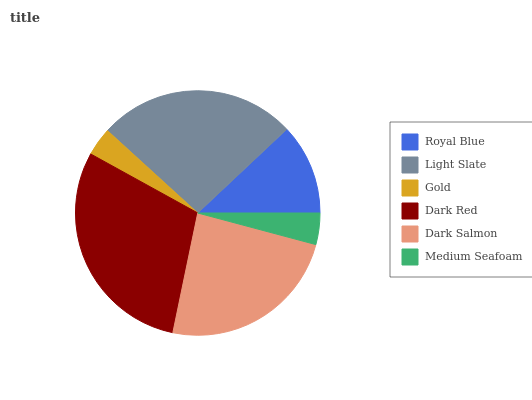Is Gold the minimum?
Answer yes or no. Yes. Is Dark Red the maximum?
Answer yes or no. Yes. Is Light Slate the minimum?
Answer yes or no. No. Is Light Slate the maximum?
Answer yes or no. No. Is Light Slate greater than Royal Blue?
Answer yes or no. Yes. Is Royal Blue less than Light Slate?
Answer yes or no. Yes. Is Royal Blue greater than Light Slate?
Answer yes or no. No. Is Light Slate less than Royal Blue?
Answer yes or no. No. Is Dark Salmon the high median?
Answer yes or no. Yes. Is Royal Blue the low median?
Answer yes or no. Yes. Is Gold the high median?
Answer yes or no. No. Is Dark Red the low median?
Answer yes or no. No. 